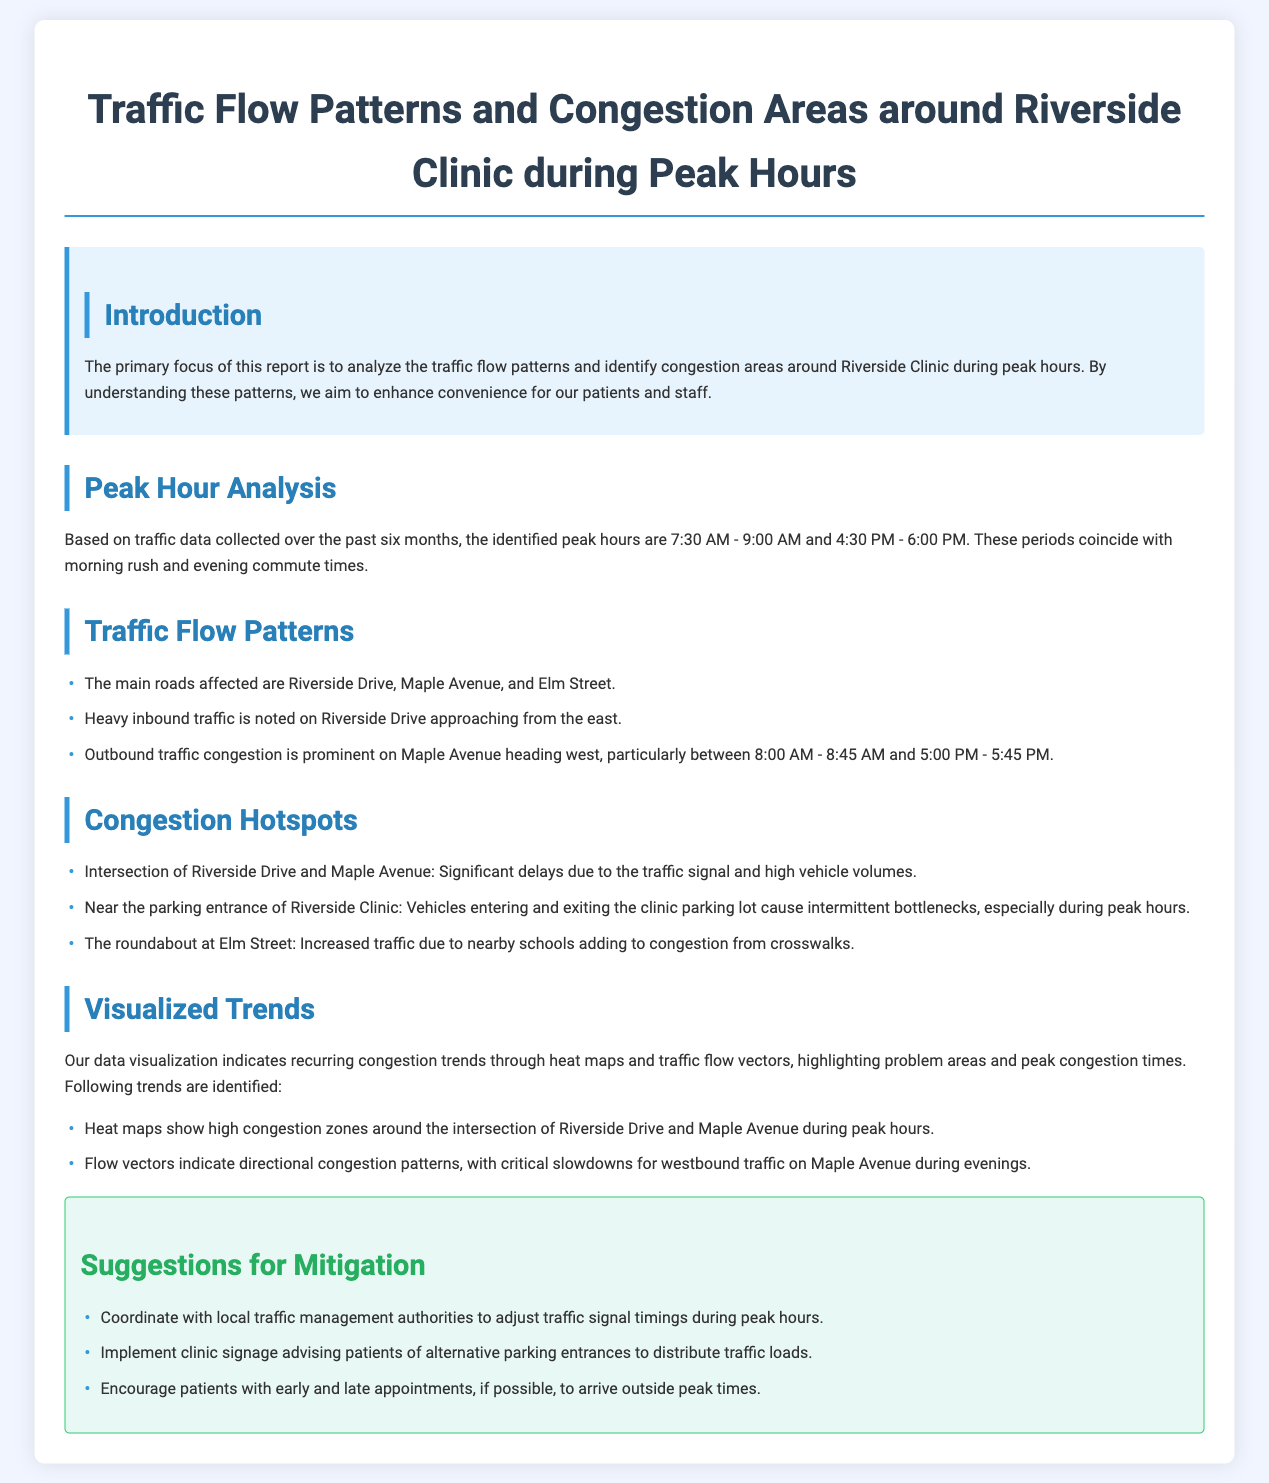What are the identified peak hours? The report specifies the peak hours as the times with the most traffic congestion around the clinic, which are 7:30 AM - 9:00 AM and 4:30 PM - 6:00 PM.
Answer: 7:30 AM - 9:00 AM and 4:30 PM - 6:00 PM Which road experiences heavy inbound traffic? The report states that Riverside Drive has heavy inbound traffic approaching from the east during peak hours.
Answer: Riverside Drive What is a significant congestion hotspot mentioned in the report? The report lists the intersection of Riverside Drive and Maple Avenue as a congestion hotspot due to significant delays.
Answer: Intersection of Riverside Drive and Maple Avenue What suggestion is made for patients with appointments? The report suggests encouraging patients with early or late appointments to arrive outside peak times to mitigate congestion.
Answer: Arrive outside peak times What is the primary goal of analyzing traffic flow patterns? The report indicates that the primary goal is to enhance convenience for patients and staff at the Riverside Clinic by understanding traffic patterns.
Answer: Enhance convenience What does the heat map indicate about congestion areas? The heat maps show high congestion zones around the intersection of Riverside Drive and Maple Avenue during peak hours.
Answer: High congestion zones around the intersection of Riverside Drive and Maple Avenue During which time does outbound traffic congestion peak on Maple Avenue? The report specifies the peak outbound traffic congestion occurs on Maple Avenue particularly between 8:00 AM - 8:45 AM and 5:00 PM - 5:45 PM.
Answer: 8:00 AM - 8:45 AM and 5:00 PM - 5:45 PM 